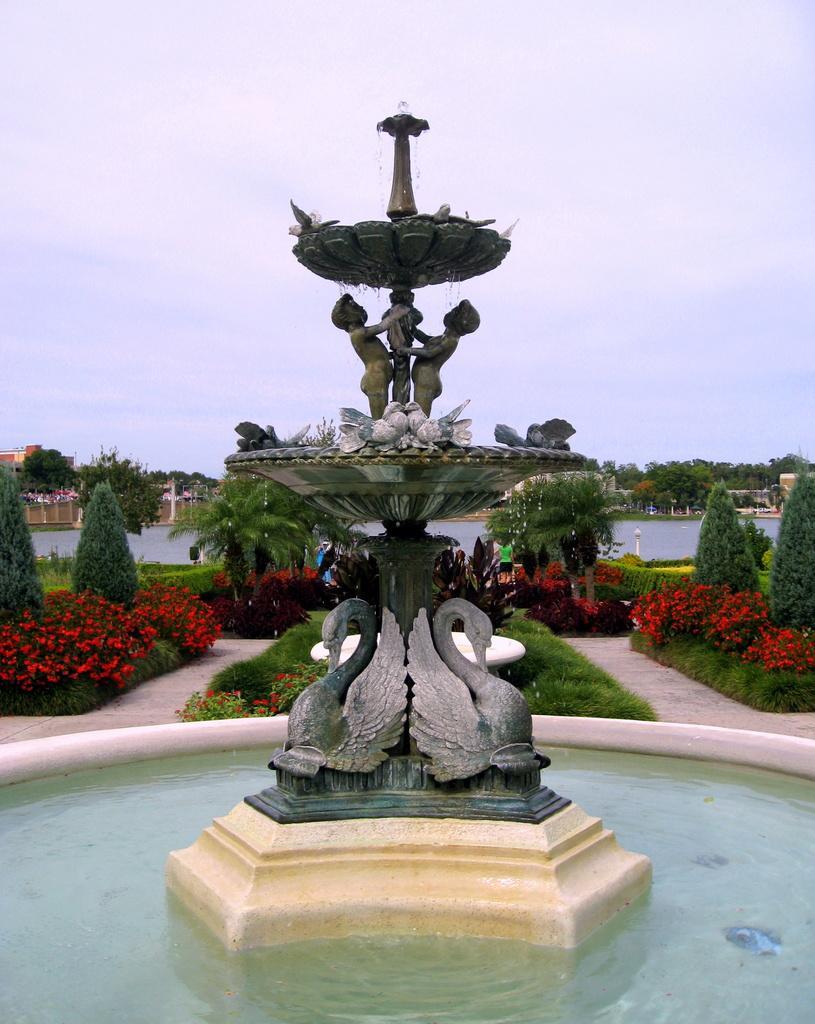Can you describe this image briefly? This image consists of a fountain. At the bottom, there is water. In the background, there are trees and plants. At the top, there is sky. 